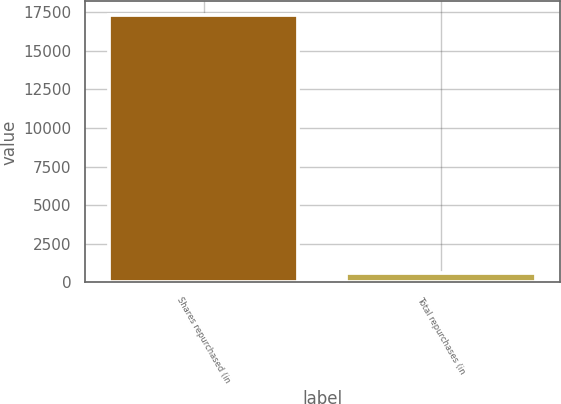Convert chart. <chart><loc_0><loc_0><loc_500><loc_500><bar_chart><fcel>Shares repurchased (in<fcel>Total repurchases (in<nl><fcel>17338<fcel>575<nl></chart> 